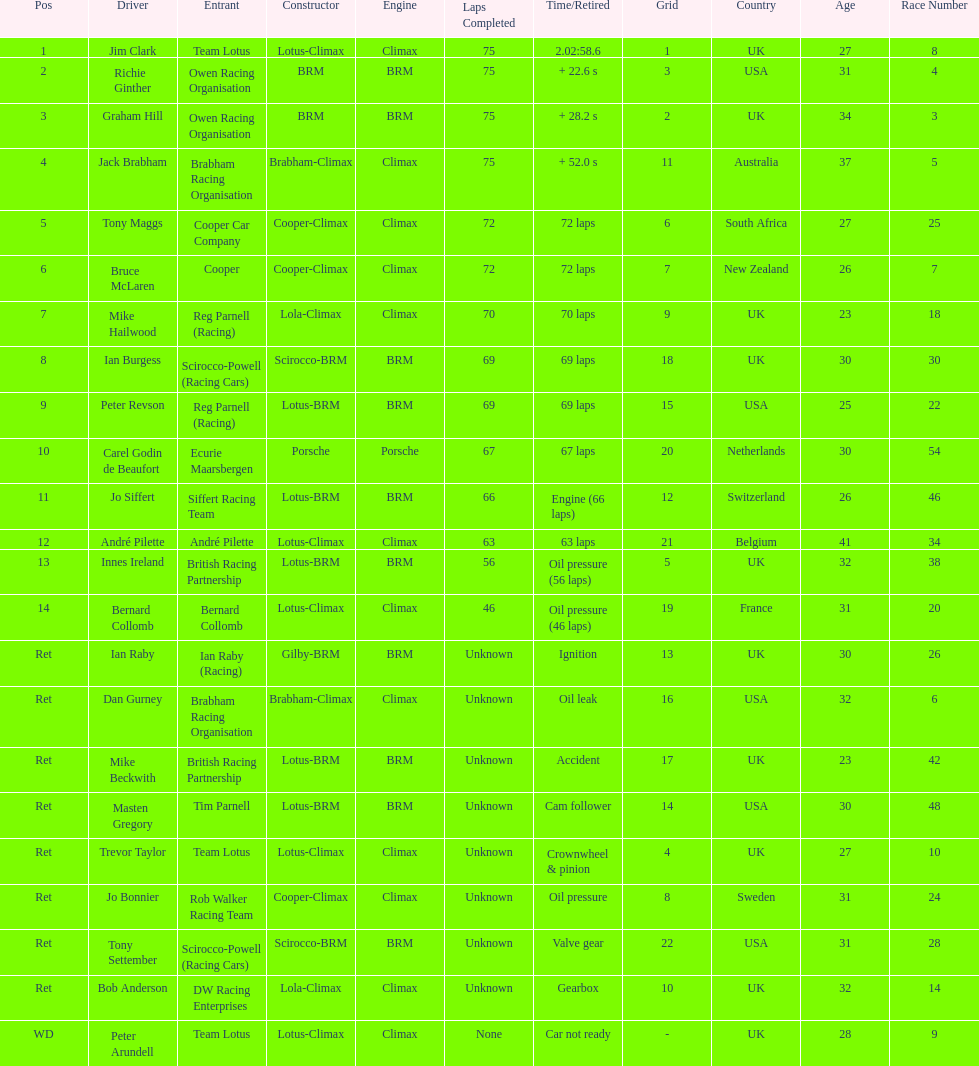What is the number of americans in the top 5? 1. 